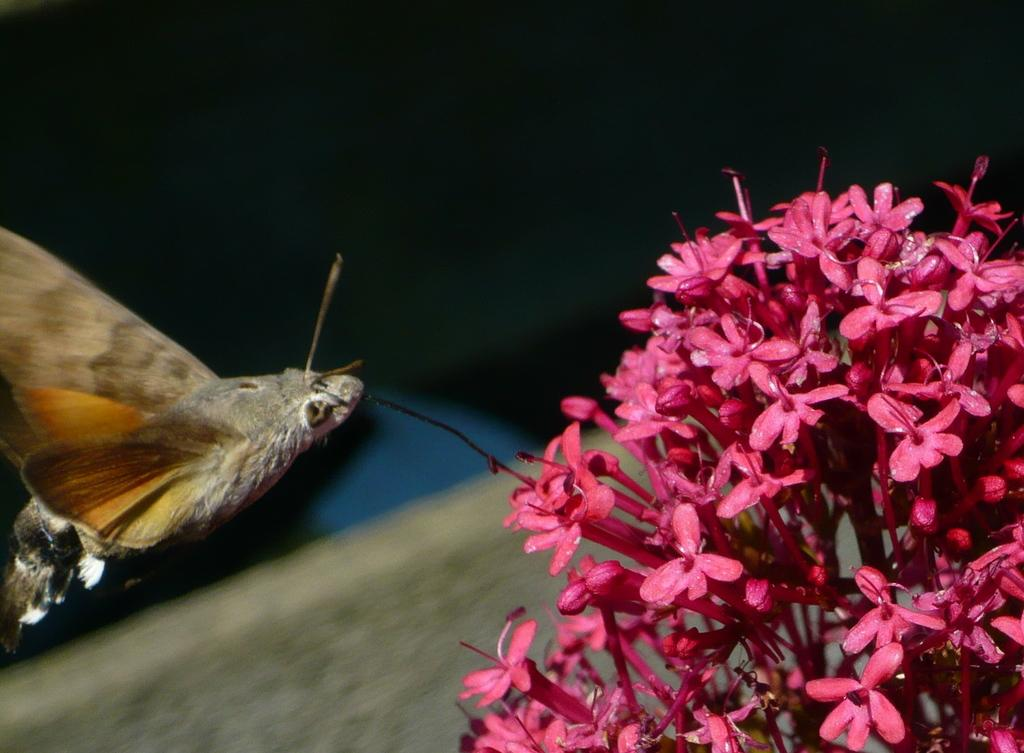What type of creature can be seen in the image? There is a butterfly in the image. What color are the flowers on the right side of the image? The flowers on the right side of the image are pink. Can you describe the background of the image? The background of the image is blurred. What type of eggs can be seen in the image? There are no eggs present in the image. What arithmetic problem can be solved using the flowers in the image? There is no arithmetic problem related to the flowers in the image. 